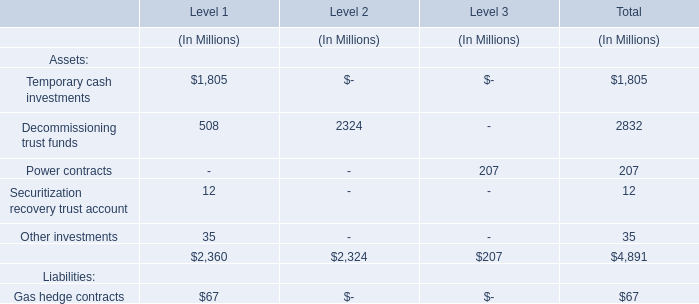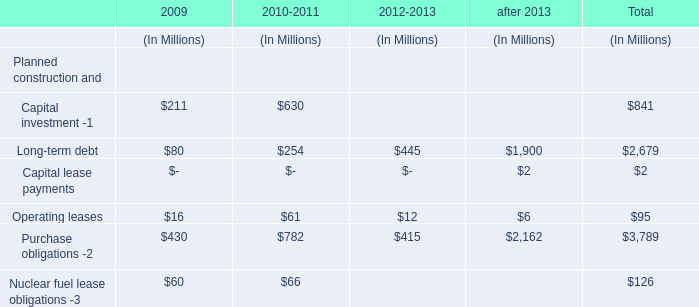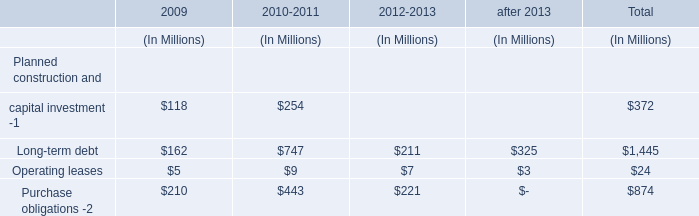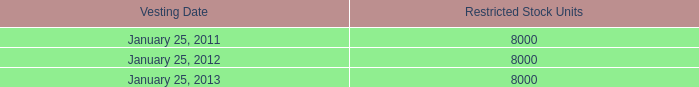what is the total number of restricted units expected to vest in the upcoming years? 
Computations: ((8000 + 8000) + 8000)
Answer: 24000.0. 